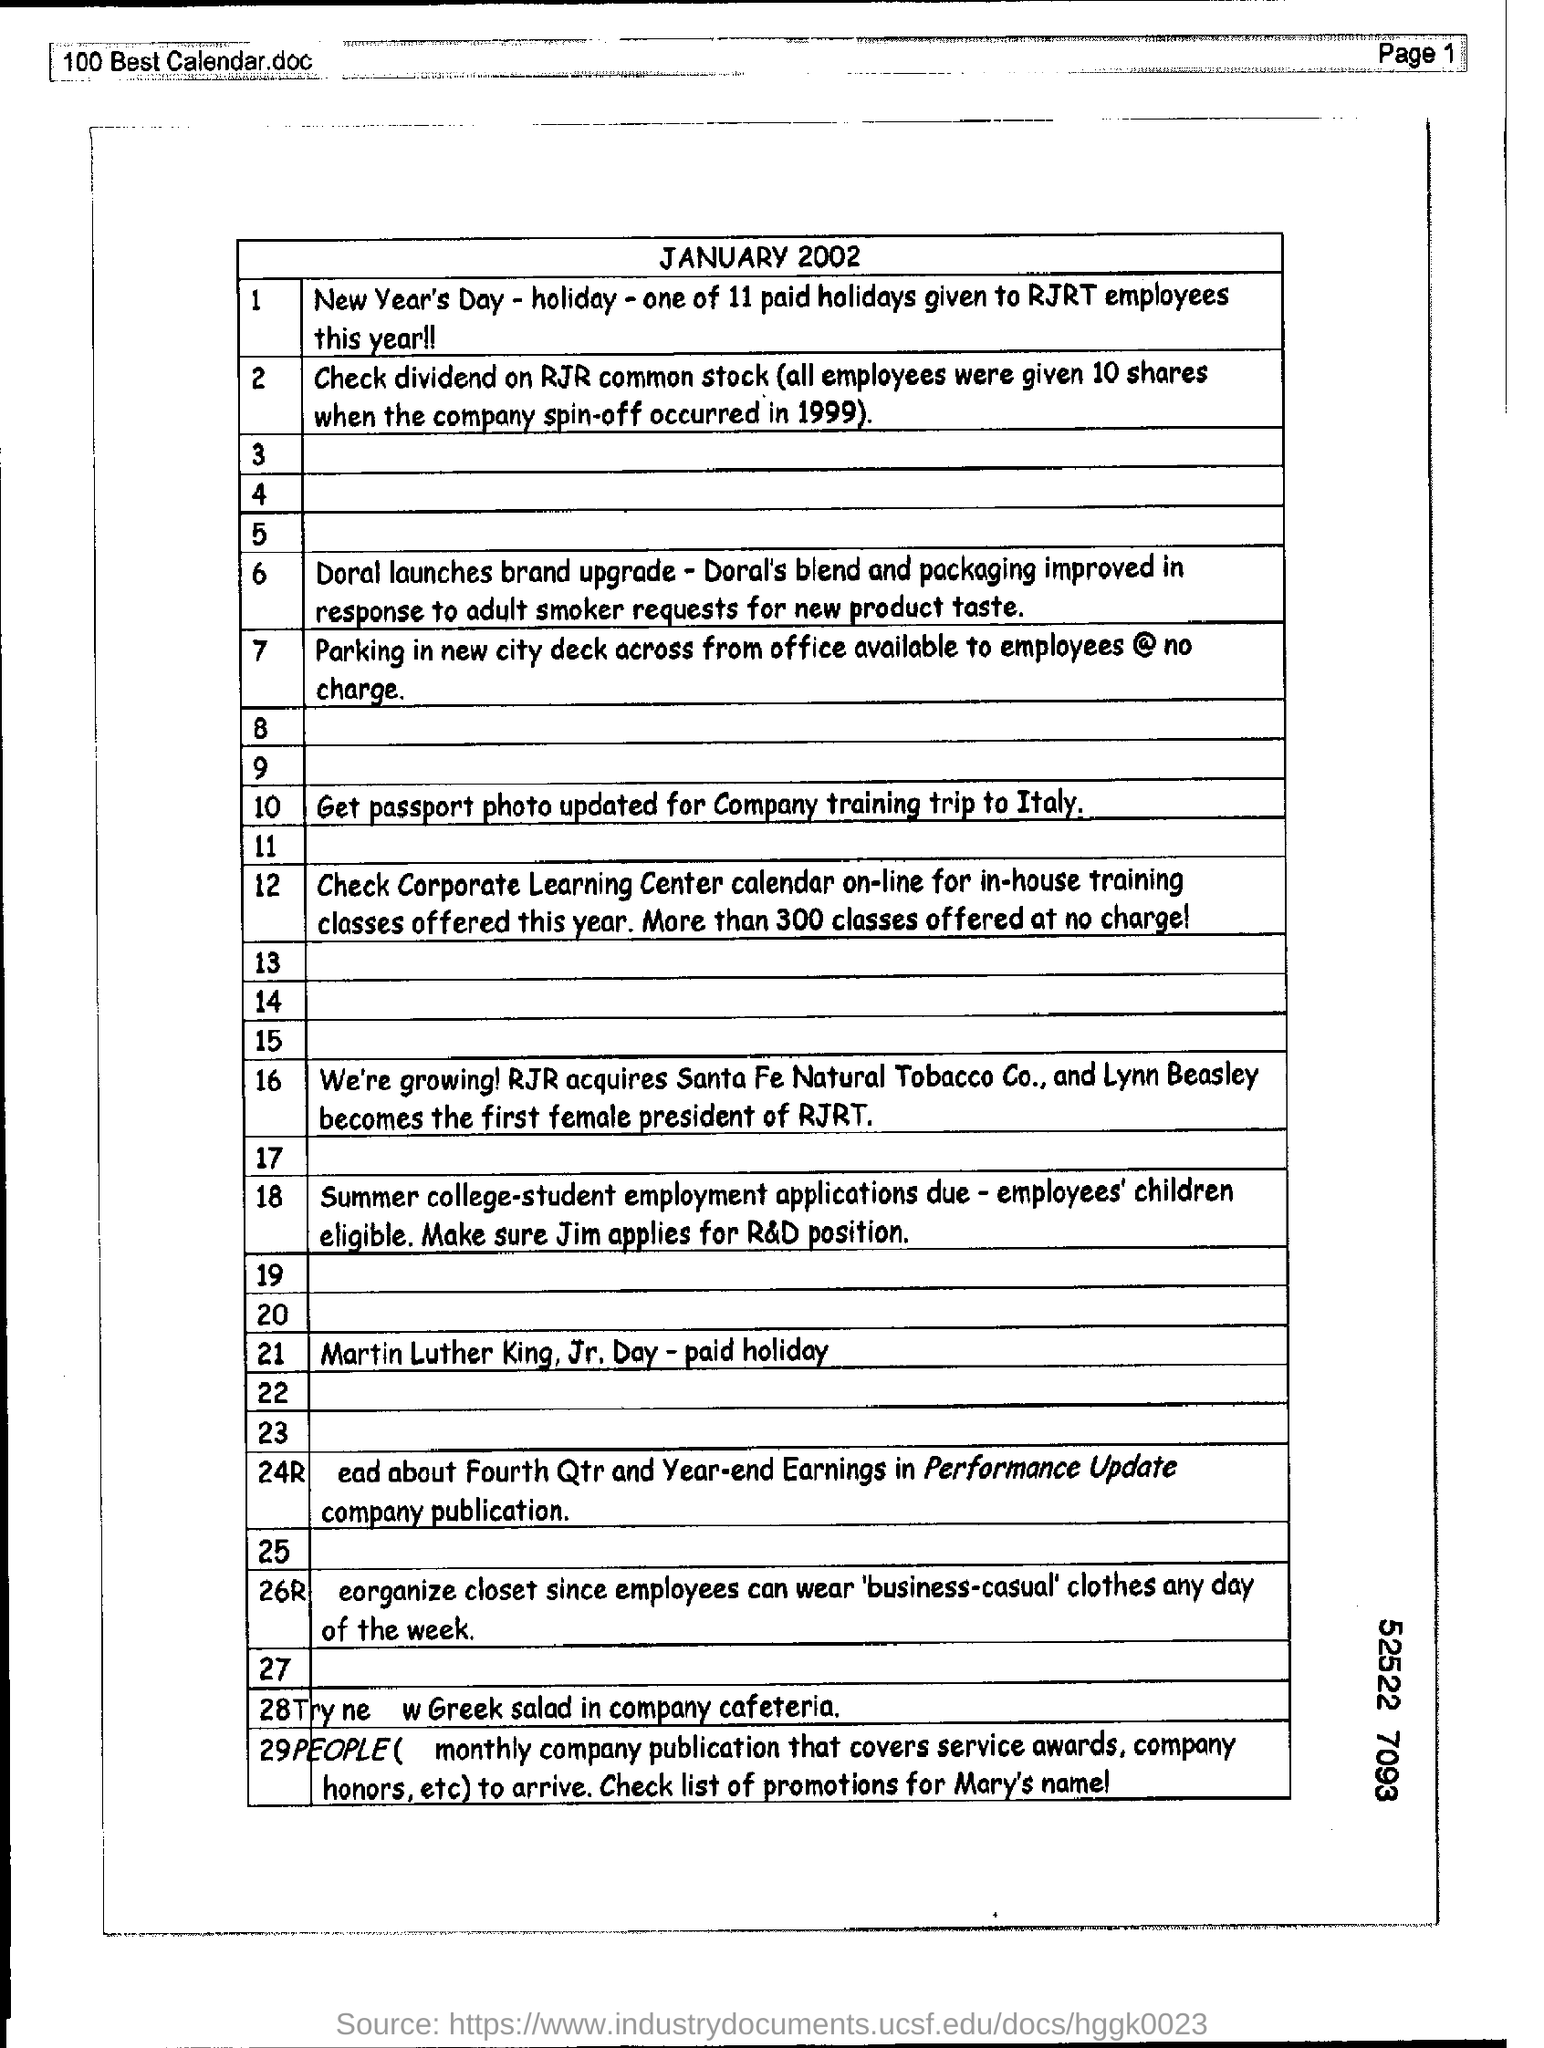What is date mention in this document?
Make the answer very short. JANUARY 2002. How many holidays paid or given to rjrt employees this year ?
Keep it short and to the point. 11. How many shares were given by the all employees?
Provide a succinct answer. 10. In which year the company spin-off occurred ?
Provide a short and direct response. 1999. Who lauches brand upgrade?
Offer a terse response. Doral. How many classes offered at no charge ?
Offer a terse response. 300. 